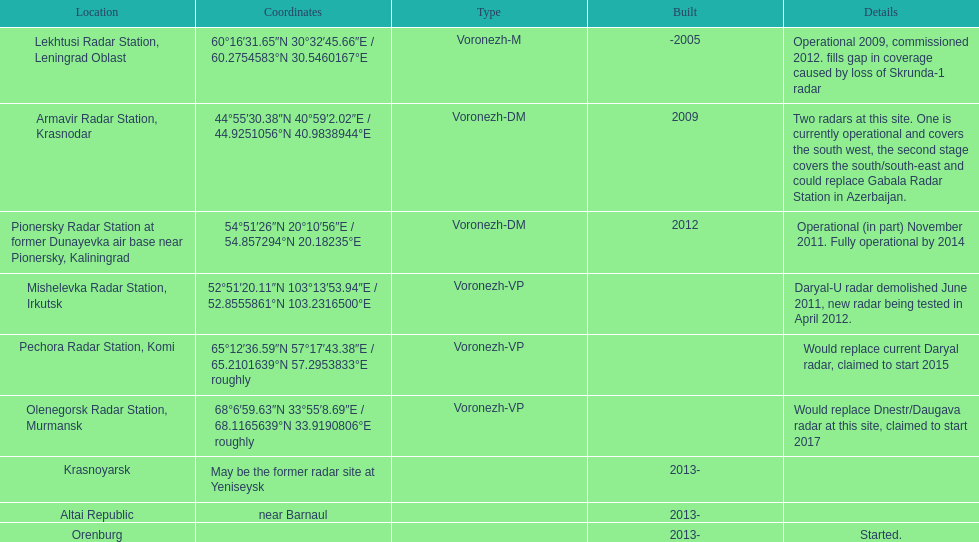What are all of the locations? Lekhtusi Radar Station, Leningrad Oblast, Armavir Radar Station, Krasnodar, Pionersky Radar Station at former Dunayevka air base near Pionersky, Kaliningrad, Mishelevka Radar Station, Irkutsk, Pechora Radar Station, Komi, Olenegorsk Radar Station, Murmansk, Krasnoyarsk, Altai Republic, Orenburg. And which location's coordinates are 60deg16'31.65''n 30deg32'45.66''e / 60.2754583degn 30.5460167dege? Lekhtusi Radar Station, Leningrad Oblast. 